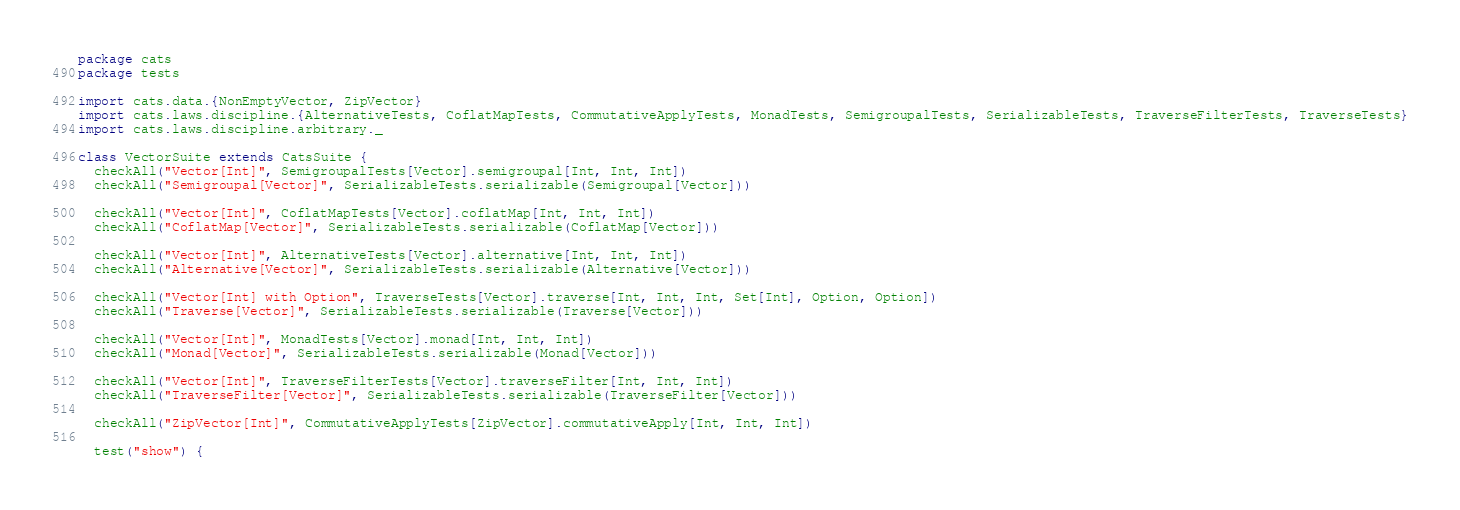<code> <loc_0><loc_0><loc_500><loc_500><_Scala_>package cats
package tests

import cats.data.{NonEmptyVector, ZipVector}
import cats.laws.discipline.{AlternativeTests, CoflatMapTests, CommutativeApplyTests, MonadTests, SemigroupalTests, SerializableTests, TraverseFilterTests, TraverseTests}
import cats.laws.discipline.arbitrary._

class VectorSuite extends CatsSuite {
  checkAll("Vector[Int]", SemigroupalTests[Vector].semigroupal[Int, Int, Int])
  checkAll("Semigroupal[Vector]", SerializableTests.serializable(Semigroupal[Vector]))

  checkAll("Vector[Int]", CoflatMapTests[Vector].coflatMap[Int, Int, Int])
  checkAll("CoflatMap[Vector]", SerializableTests.serializable(CoflatMap[Vector]))

  checkAll("Vector[Int]", AlternativeTests[Vector].alternative[Int, Int, Int])
  checkAll("Alternative[Vector]", SerializableTests.serializable(Alternative[Vector]))

  checkAll("Vector[Int] with Option", TraverseTests[Vector].traverse[Int, Int, Int, Set[Int], Option, Option])
  checkAll("Traverse[Vector]", SerializableTests.serializable(Traverse[Vector]))

  checkAll("Vector[Int]", MonadTests[Vector].monad[Int, Int, Int])
  checkAll("Monad[Vector]", SerializableTests.serializable(Monad[Vector]))

  checkAll("Vector[Int]", TraverseFilterTests[Vector].traverseFilter[Int, Int, Int])
  checkAll("TraverseFilter[Vector]", SerializableTests.serializable(TraverseFilter[Vector]))

  checkAll("ZipVector[Int]", CommutativeApplyTests[ZipVector].commutativeApply[Int, Int, Int])

  test("show") {</code> 